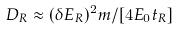Convert formula to latex. <formula><loc_0><loc_0><loc_500><loc_500>D _ { R } \approx ( \delta E _ { R } ) ^ { 2 } m / [ 4 E _ { 0 } t _ { R } ]</formula> 